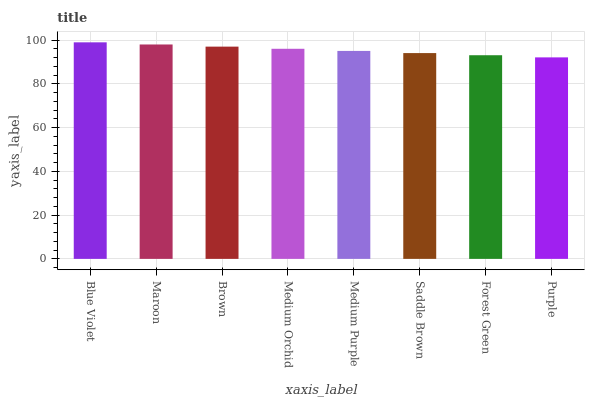Is Maroon the minimum?
Answer yes or no. No. Is Maroon the maximum?
Answer yes or no. No. Is Blue Violet greater than Maroon?
Answer yes or no. Yes. Is Maroon less than Blue Violet?
Answer yes or no. Yes. Is Maroon greater than Blue Violet?
Answer yes or no. No. Is Blue Violet less than Maroon?
Answer yes or no. No. Is Medium Orchid the high median?
Answer yes or no. Yes. Is Medium Purple the low median?
Answer yes or no. Yes. Is Maroon the high median?
Answer yes or no. No. Is Forest Green the low median?
Answer yes or no. No. 